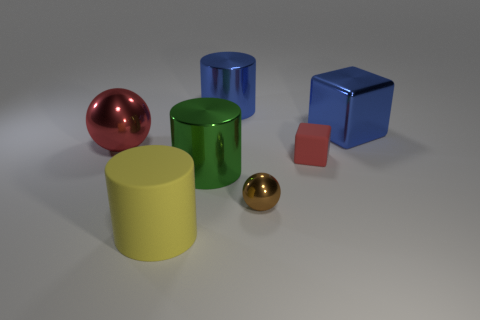Add 3 large spheres. How many objects exist? 10 Subtract all balls. How many objects are left? 5 Add 6 purple matte cylinders. How many purple matte cylinders exist? 6 Subtract 0 purple cubes. How many objects are left? 7 Subtract all small brown objects. Subtract all big green things. How many objects are left? 5 Add 1 green metallic cylinders. How many green metallic cylinders are left? 2 